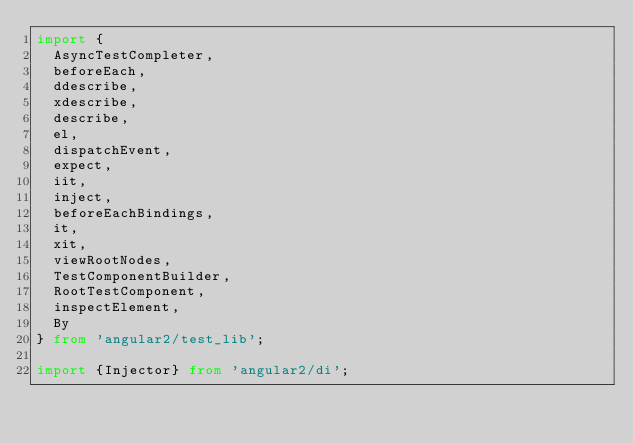<code> <loc_0><loc_0><loc_500><loc_500><_TypeScript_>import {
  AsyncTestCompleter,
  beforeEach,
  ddescribe,
  xdescribe,
  describe,
  el,
  dispatchEvent,
  expect,
  iit,
  inject,
  beforeEachBindings,
  it,
  xit,
  viewRootNodes,
  TestComponentBuilder,
  RootTestComponent,
  inspectElement,
  By
} from 'angular2/test_lib';

import {Injector} from 'angular2/di';</code> 